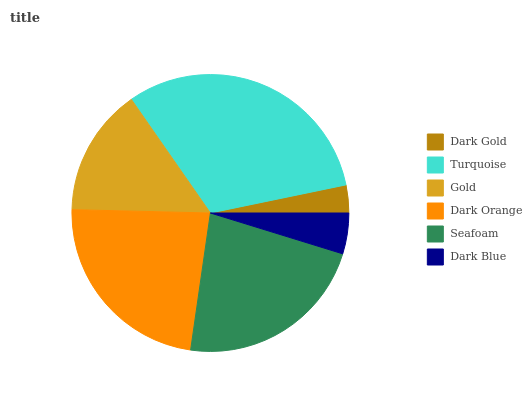Is Dark Gold the minimum?
Answer yes or no. Yes. Is Turquoise the maximum?
Answer yes or no. Yes. Is Gold the minimum?
Answer yes or no. No. Is Gold the maximum?
Answer yes or no. No. Is Turquoise greater than Gold?
Answer yes or no. Yes. Is Gold less than Turquoise?
Answer yes or no. Yes. Is Gold greater than Turquoise?
Answer yes or no. No. Is Turquoise less than Gold?
Answer yes or no. No. Is Seafoam the high median?
Answer yes or no. Yes. Is Gold the low median?
Answer yes or no. Yes. Is Dark Orange the high median?
Answer yes or no. No. Is Dark Gold the low median?
Answer yes or no. No. 